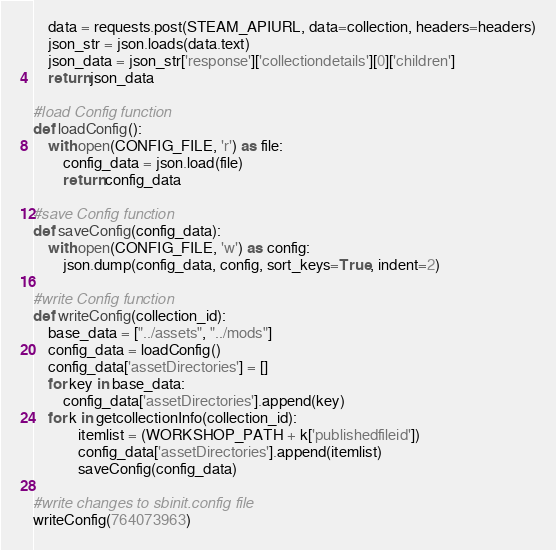Convert code to text. <code><loc_0><loc_0><loc_500><loc_500><_Python_>    data = requests.post(STEAM_APIURL, data=collection, headers=headers)
    json_str = json.loads(data.text)
    json_data = json_str['response']['collectiondetails'][0]['children']
    return json_data

#load Config function
def loadConfig():
    with open(CONFIG_FILE, 'r') as file:
        config_data = json.load(file)
        return config_data

#save Config function
def saveConfig(config_data):
    with open(CONFIG_FILE, 'w') as config:
        json.dump(config_data, config, sort_keys=True, indent=2)

#write Config function
def writeConfig(collection_id):
    base_data = ["../assets", "../mods"]
    config_data = loadConfig()
    config_data['assetDirectories'] = []
    for key in base_data:
        config_data['assetDirectories'].append(key)
    for k in getcollectionInfo(collection_id):
            itemlist = (WORKSHOP_PATH + k['publishedfileid'])
            config_data['assetDirectories'].append(itemlist)
            saveConfig(config_data)

#write changes to sbinit.config file
writeConfig(764073963)
</code> 